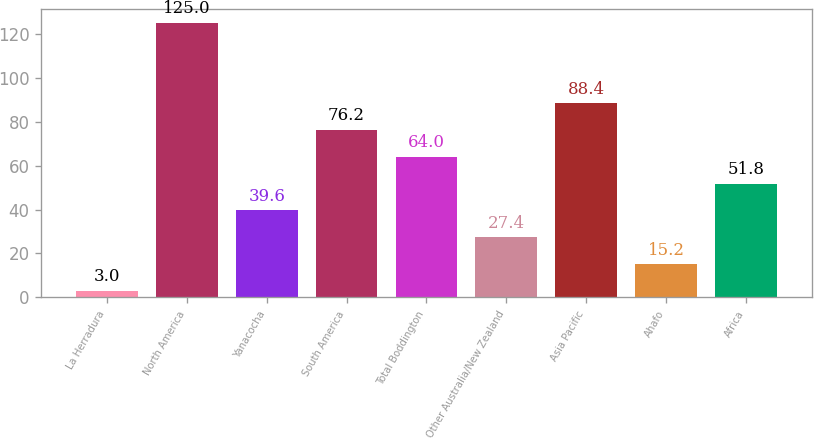Convert chart. <chart><loc_0><loc_0><loc_500><loc_500><bar_chart><fcel>La Herradura<fcel>North America<fcel>Yanacocha<fcel>South America<fcel>Total Boddington<fcel>Other Australia/New Zealand<fcel>Asia Pacific<fcel>Ahafo<fcel>Africa<nl><fcel>3<fcel>125<fcel>39.6<fcel>76.2<fcel>64<fcel>27.4<fcel>88.4<fcel>15.2<fcel>51.8<nl></chart> 